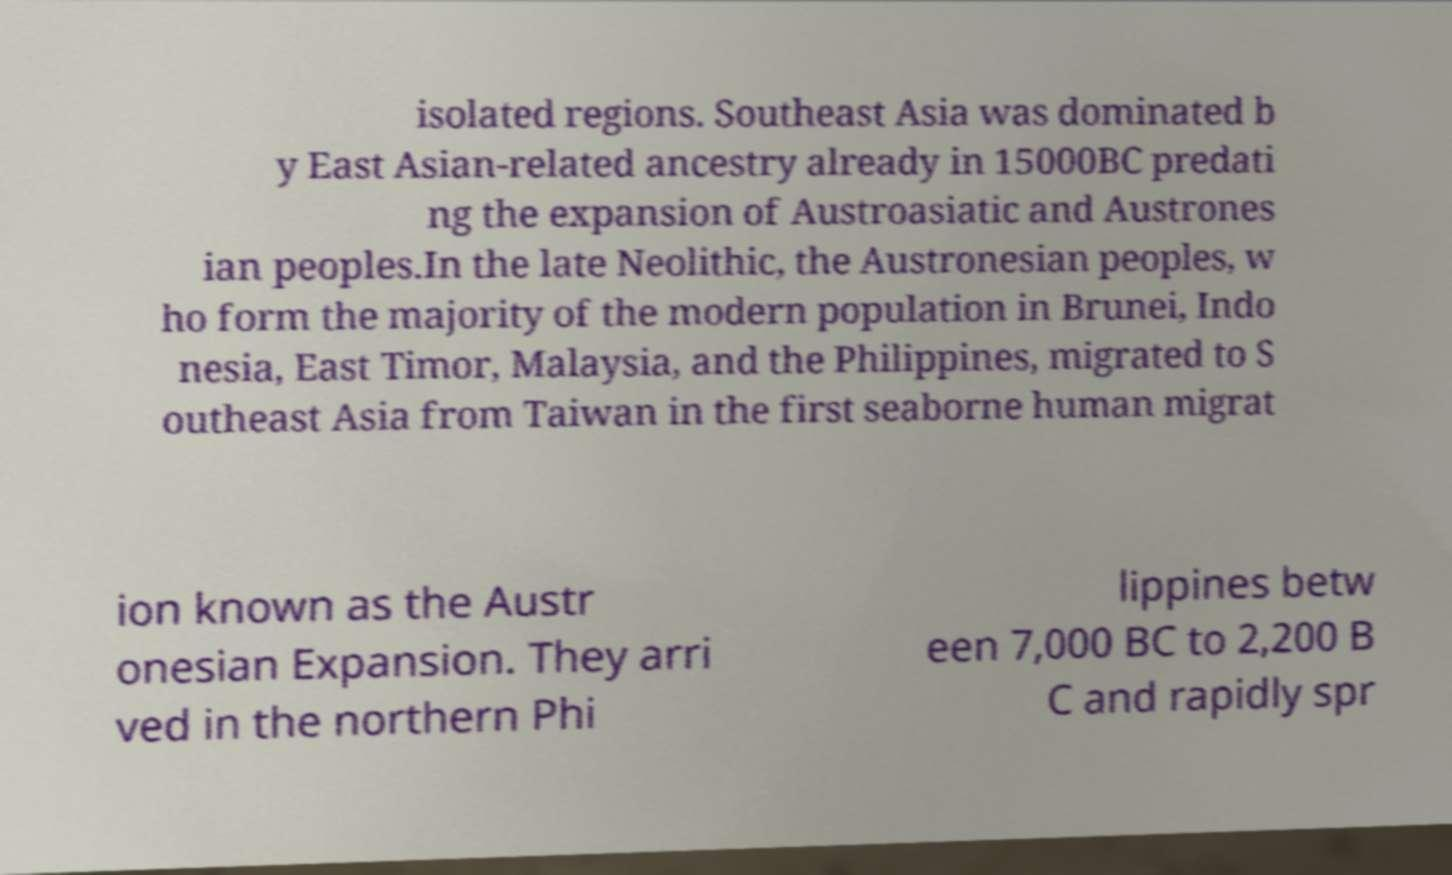Please read and relay the text visible in this image. What does it say? isolated regions. Southeast Asia was dominated b y East Asian-related ancestry already in 15000BC predati ng the expansion of Austroasiatic and Austrones ian peoples.In the late Neolithic, the Austronesian peoples, w ho form the majority of the modern population in Brunei, Indo nesia, East Timor, Malaysia, and the Philippines, migrated to S outheast Asia from Taiwan in the first seaborne human migrat ion known as the Austr onesian Expansion. They arri ved in the northern Phi lippines betw een 7,000 BC to 2,200 B C and rapidly spr 